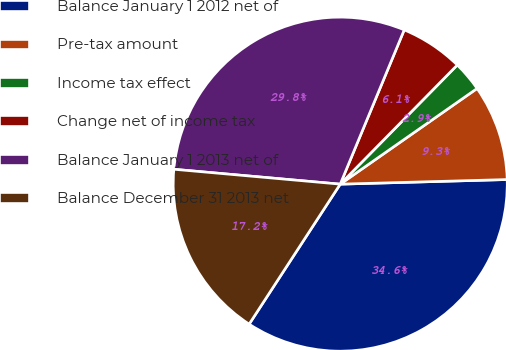Convert chart to OTSL. <chart><loc_0><loc_0><loc_500><loc_500><pie_chart><fcel>Balance January 1 2012 net of<fcel>Pre-tax amount<fcel>Income tax effect<fcel>Change net of income tax<fcel>Balance January 1 2013 net of<fcel>Balance December 31 2013 net<nl><fcel>34.62%<fcel>9.27%<fcel>2.93%<fcel>6.1%<fcel>29.84%<fcel>17.24%<nl></chart> 